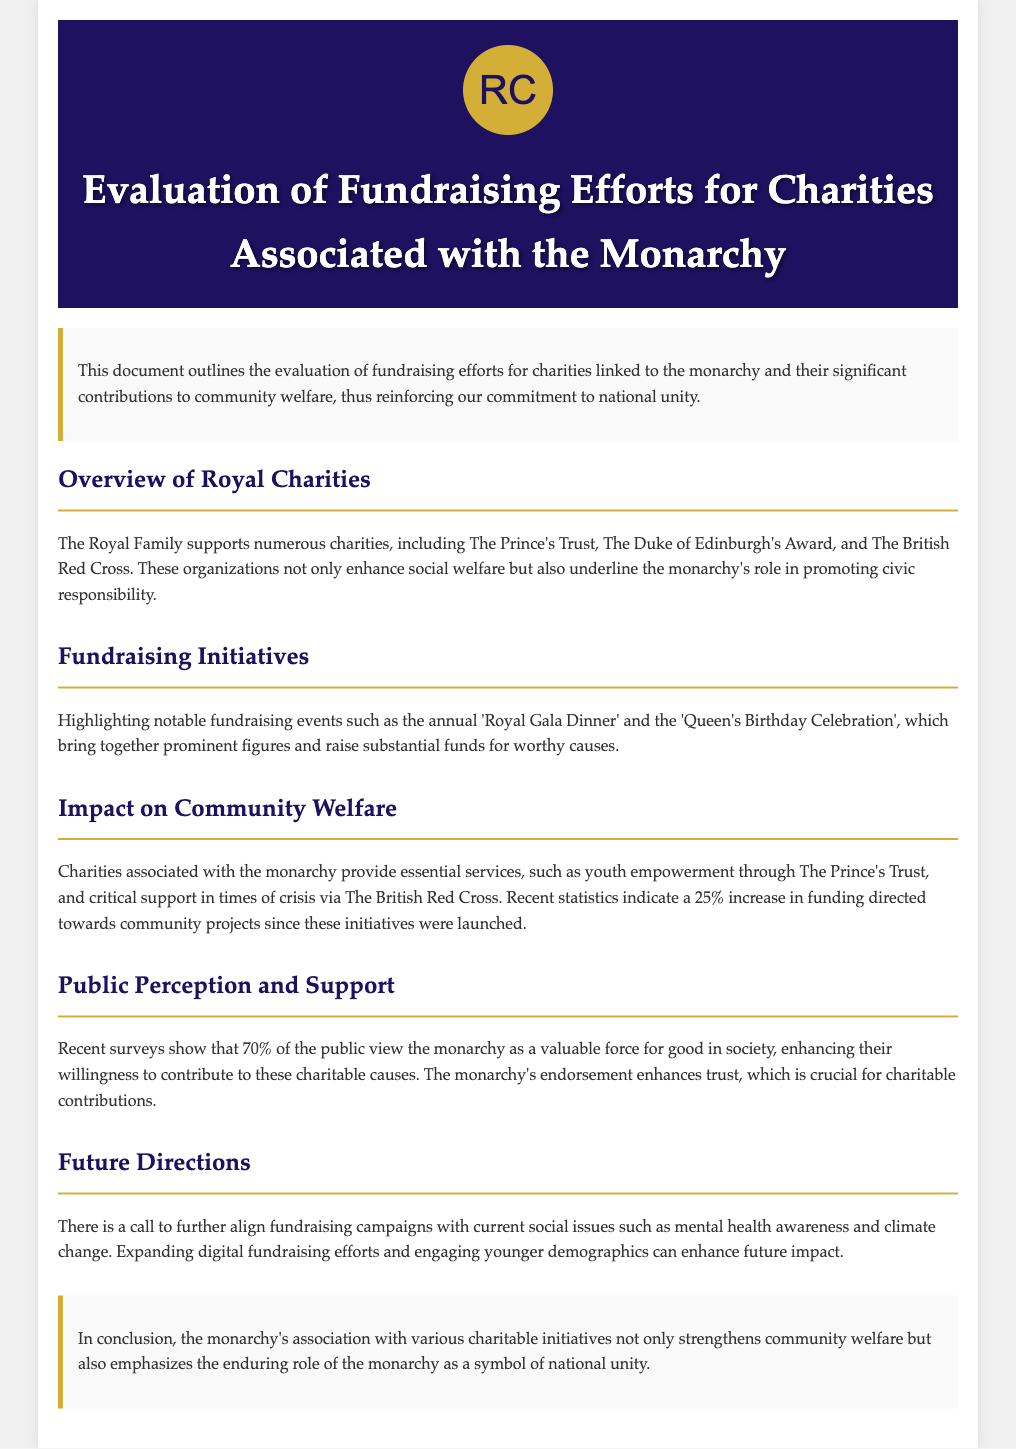what is the title of the document? The title is specified in the header section of the document.
Answer: Evaluation of Fundraising Efforts for Charities Associated with the Monarchy which charity is associated with youth empowerment? The document mentions The Prince's Trust as an organization that provides youth empowerment services.
Answer: The Prince's Trust what percentage increase in funding is mentioned for community projects? The document states a specific increase in funding towards community projects since initiatives were launched.
Answer: 25% how many percent of the public view the monarchy positively? A survey indicated a measurable percentage of public opinion regarding the monarchy's social value.
Answer: 70% name one notable fundraising event highlighted in the document. The document lists several events and one is explicitly mentioned as notable for its fundraising significance.
Answer: Royal Gala Dinner what future social issue does the document suggest for fundraising alignment? The document discusses aligning future fundraising efforts with current pressing social challenges.
Answer: mental health awareness which organization's work includes critical support during crises? The document identifies one organization specifically mentioned for its role in crisis support.
Answer: The British Red Cross what is the primary role of the monarchy as stated in the document? The document emphasizes a particular symbolic significance attributed to the monarchy.
Answer: national unity what section follows the overview of royal charities? The document is organized into sections and lists topics sequentially, indicating the next after the overview.
Answer: Fundraising Initiatives 